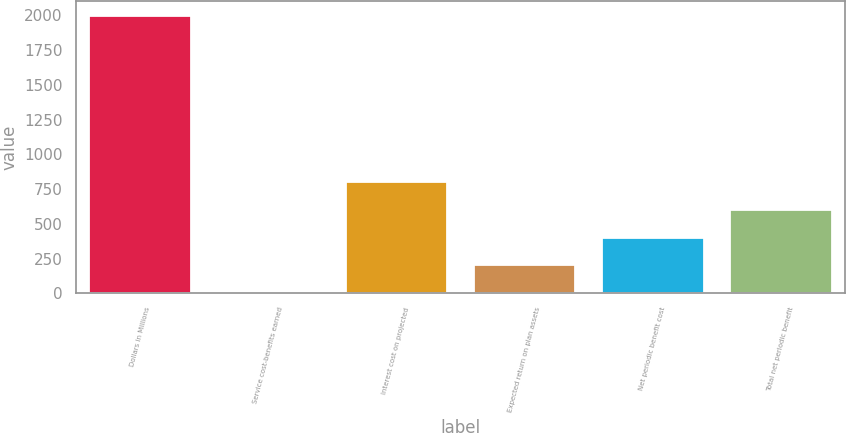Convert chart. <chart><loc_0><loc_0><loc_500><loc_500><bar_chart><fcel>Dollars in Millions<fcel>Service cost-benefits earned<fcel>Interest cost on projected<fcel>Expected return on plan assets<fcel>Net periodic benefit cost<fcel>Total net periodic benefit<nl><fcel>2004<fcel>8<fcel>806.4<fcel>207.6<fcel>407.2<fcel>606.8<nl></chart> 